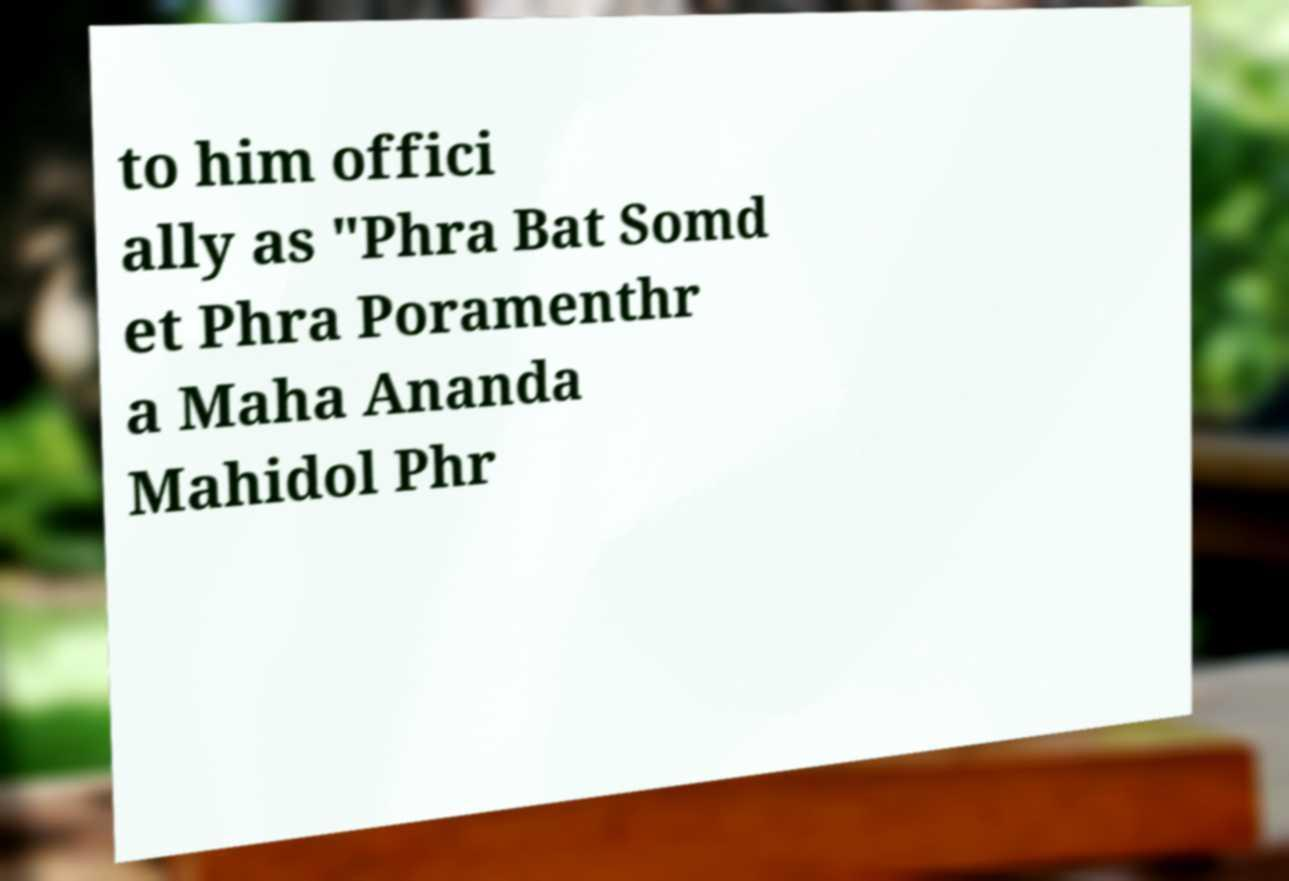What messages or text are displayed in this image? I need them in a readable, typed format. to him offici ally as "Phra Bat Somd et Phra Poramenthr a Maha Ananda Mahidol Phr 